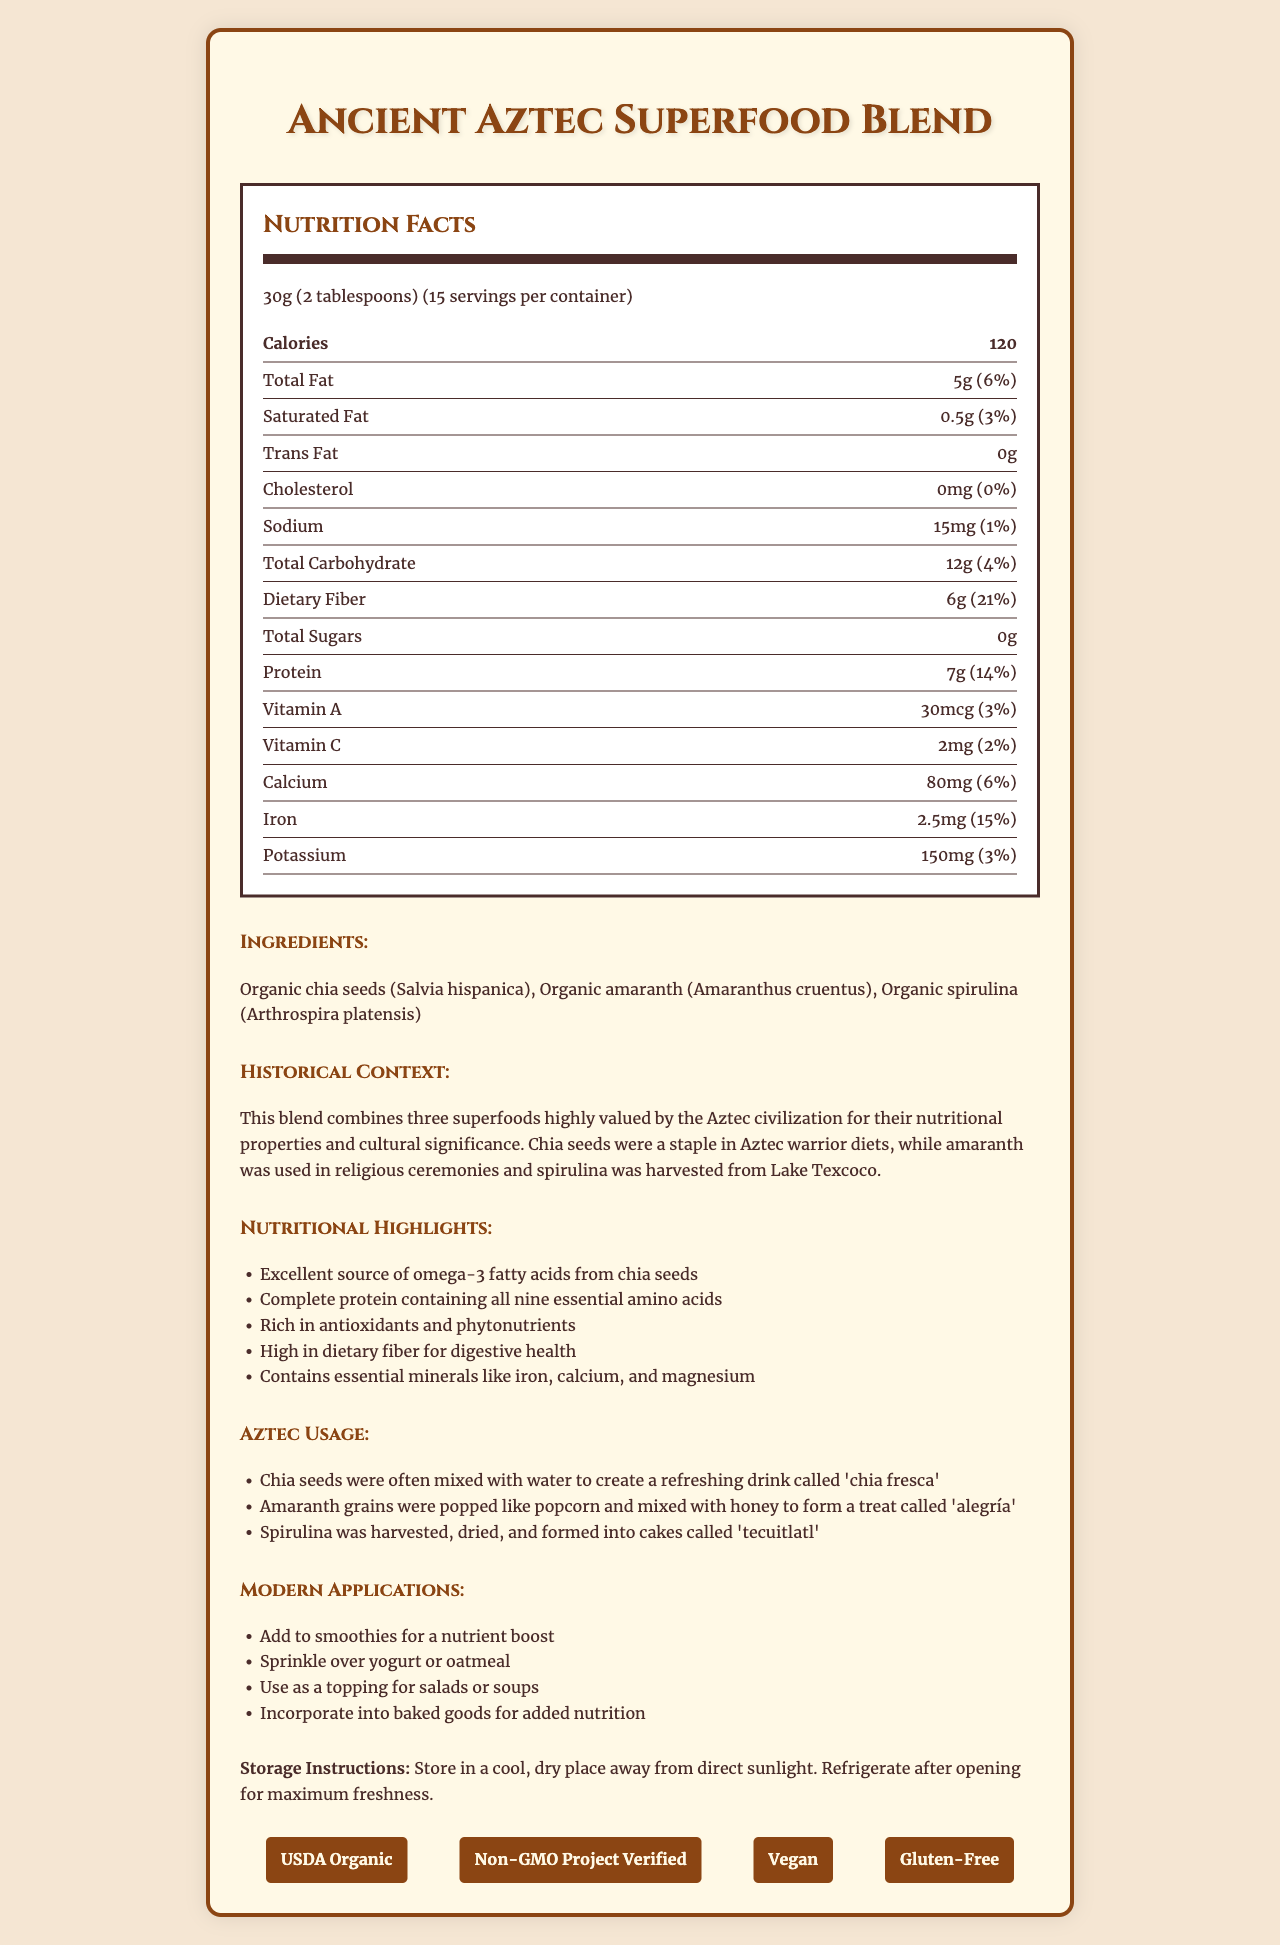what is the serving size? The serving size is indicated as "30g (2 tablespoons)" in the nutrition facts section.
Answer: 30g (2 tablespoons) what is the total fat per serving? The total fat per serving is listed as 5g in the nutrition facts section.
Answer: 5g what percentage of the daily value does the dietary fiber per serving provide? The dietary fiber per serving provides 21% of the daily value as mentioned under the nutritional label.
Answer: 21% how many grams of protein are in one serving? One serving contains 7g of protein, which is clearly noted in the nutrition facts.
Answer: 7g what ingredients are listed in this superfood blend? The ingredients are listed in the ingredients section of the document.
Answer: Organic chia seeds (Salvia hispanica), Organic amaranth (Amaranthus cruentus), Organic spirulina (Arthrospira platensis) which document certification indicates the product is free from genetic modification? A. USDA Organic B. Gluten-Free C. Non-GMO Project Verified The Non-GMO Project Verified certification indicates that the product is free from genetic modification.
Answer: C. Non-GMO Project Verified what historical use did the Aztecs have for chia seeds? A. Mixed with honey B. Used in ceremonies C. Mixed with water The document notes that chia seeds were mixed with water to create a drink called 'chia fresca'.
Answer: C. Mixed with water is this product suitable for vegans? The document lists "Vegan" as one of the certifications, indicating it is suitable for vegans.
Answer: Yes does the product contain any cholesterol? The nutrition label shows cholesterol amount as "0mg" and indicates a percent daily value of "0%".
Answer: No summarize the main idea of the document. The document introduces the Ancient Aztec Superfood Blend, outlines its nutritional value and benefits, and explores historical and modern uses. It also provides storage instructions and lists quality certifications.
Answer: The document provides detailed information about the Ancient Aztec Superfood Blend, including its nutritional facts, ingredients, historical context, and modern applications. It highlights the health benefits of the blend, such as being a rich source of omega-3 fatty acids, complete protein, and antioxidants. Additionally, it lists certifications guaranteeing the product's quality and storage instructions to maintain its freshness. what is the exact amount of daily iron percentage recommended for adults? The document shows the iron percentage provided by a serving of the product but does not specify the exact daily recommended value for adults.
Answer: Not enough information 